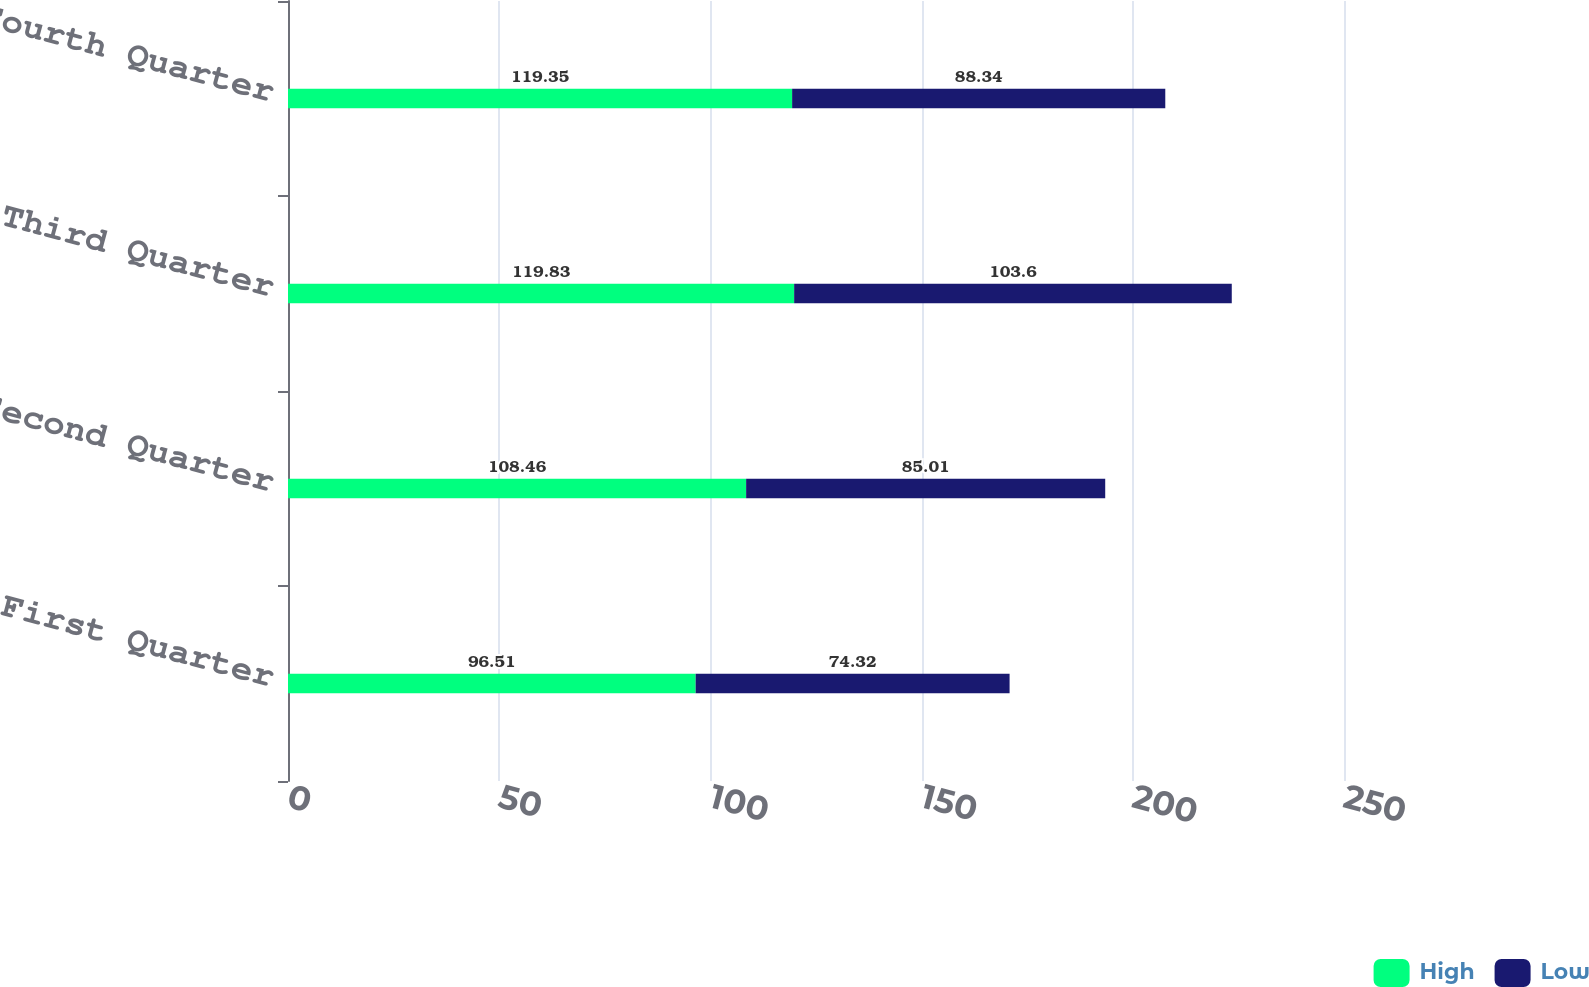<chart> <loc_0><loc_0><loc_500><loc_500><stacked_bar_chart><ecel><fcel>First Quarter<fcel>Second Quarter<fcel>Third Quarter<fcel>Fourth Quarter<nl><fcel>High<fcel>96.51<fcel>108.46<fcel>119.83<fcel>119.35<nl><fcel>Low<fcel>74.32<fcel>85.01<fcel>103.6<fcel>88.34<nl></chart> 